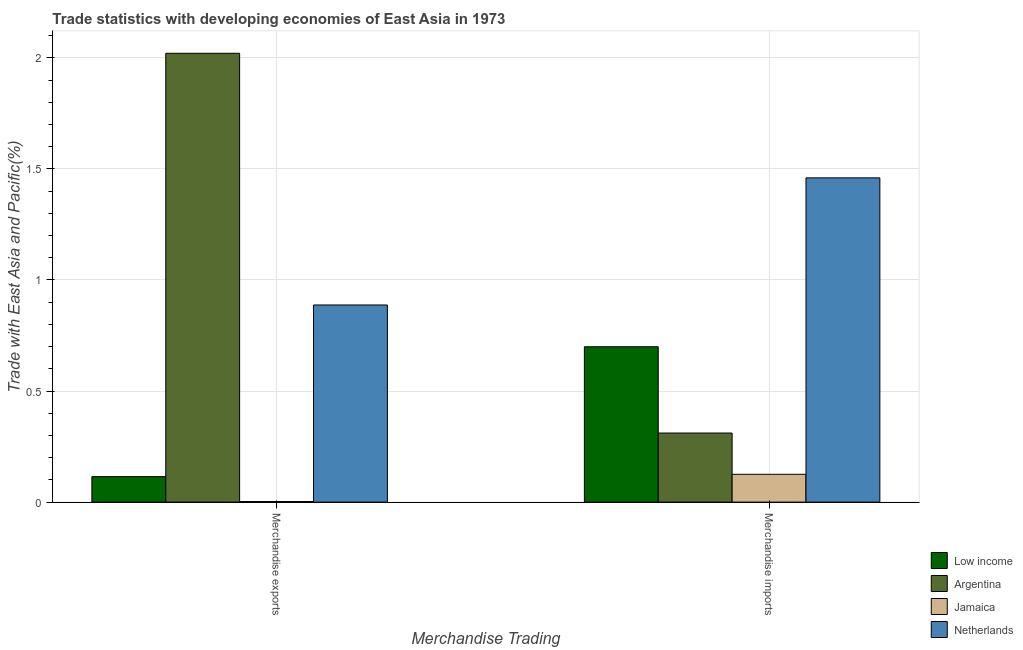How many different coloured bars are there?
Your response must be concise. 4. How many groups of bars are there?
Provide a succinct answer. 2. What is the label of the 1st group of bars from the left?
Ensure brevity in your answer.  Merchandise exports. What is the merchandise exports in Argentina?
Your response must be concise. 2.02. Across all countries, what is the maximum merchandise exports?
Offer a terse response. 2.02. Across all countries, what is the minimum merchandise exports?
Ensure brevity in your answer.  0. In which country was the merchandise exports maximum?
Make the answer very short. Argentina. In which country was the merchandise imports minimum?
Your answer should be very brief. Jamaica. What is the total merchandise exports in the graph?
Provide a short and direct response. 3.03. What is the difference between the merchandise imports in Netherlands and that in Jamaica?
Make the answer very short. 1.33. What is the difference between the merchandise imports in Low income and the merchandise exports in Jamaica?
Provide a succinct answer. 0.7. What is the average merchandise imports per country?
Your response must be concise. 0.65. What is the difference between the merchandise exports and merchandise imports in Low income?
Offer a very short reply. -0.58. What is the ratio of the merchandise exports in Netherlands to that in Low income?
Give a very brief answer. 7.74. Is the merchandise exports in Jamaica less than that in Netherlands?
Offer a very short reply. Yes. What does the 2nd bar from the right in Merchandise imports represents?
Give a very brief answer. Jamaica. How many bars are there?
Keep it short and to the point. 8. Are all the bars in the graph horizontal?
Make the answer very short. No. How many countries are there in the graph?
Make the answer very short. 4. What is the difference between two consecutive major ticks on the Y-axis?
Keep it short and to the point. 0.5. Are the values on the major ticks of Y-axis written in scientific E-notation?
Your answer should be very brief. No. Does the graph contain any zero values?
Ensure brevity in your answer.  No. Does the graph contain grids?
Your response must be concise. Yes. Where does the legend appear in the graph?
Your answer should be compact. Bottom right. How many legend labels are there?
Make the answer very short. 4. What is the title of the graph?
Your response must be concise. Trade statistics with developing economies of East Asia in 1973. What is the label or title of the X-axis?
Your response must be concise. Merchandise Trading. What is the label or title of the Y-axis?
Provide a succinct answer. Trade with East Asia and Pacific(%). What is the Trade with East Asia and Pacific(%) in Low income in Merchandise exports?
Make the answer very short. 0.11. What is the Trade with East Asia and Pacific(%) of Argentina in Merchandise exports?
Make the answer very short. 2.02. What is the Trade with East Asia and Pacific(%) of Jamaica in Merchandise exports?
Provide a succinct answer. 0. What is the Trade with East Asia and Pacific(%) of Netherlands in Merchandise exports?
Your response must be concise. 0.89. What is the Trade with East Asia and Pacific(%) of Low income in Merchandise imports?
Ensure brevity in your answer.  0.7. What is the Trade with East Asia and Pacific(%) of Argentina in Merchandise imports?
Your answer should be compact. 0.31. What is the Trade with East Asia and Pacific(%) in Jamaica in Merchandise imports?
Provide a succinct answer. 0.13. What is the Trade with East Asia and Pacific(%) of Netherlands in Merchandise imports?
Provide a succinct answer. 1.46. Across all Merchandise Trading, what is the maximum Trade with East Asia and Pacific(%) of Low income?
Your answer should be compact. 0.7. Across all Merchandise Trading, what is the maximum Trade with East Asia and Pacific(%) of Argentina?
Give a very brief answer. 2.02. Across all Merchandise Trading, what is the maximum Trade with East Asia and Pacific(%) of Jamaica?
Provide a short and direct response. 0.13. Across all Merchandise Trading, what is the maximum Trade with East Asia and Pacific(%) of Netherlands?
Keep it short and to the point. 1.46. Across all Merchandise Trading, what is the minimum Trade with East Asia and Pacific(%) in Low income?
Ensure brevity in your answer.  0.11. Across all Merchandise Trading, what is the minimum Trade with East Asia and Pacific(%) in Argentina?
Give a very brief answer. 0.31. Across all Merchandise Trading, what is the minimum Trade with East Asia and Pacific(%) of Jamaica?
Your response must be concise. 0. Across all Merchandise Trading, what is the minimum Trade with East Asia and Pacific(%) of Netherlands?
Your answer should be compact. 0.89. What is the total Trade with East Asia and Pacific(%) in Low income in the graph?
Provide a succinct answer. 0.81. What is the total Trade with East Asia and Pacific(%) in Argentina in the graph?
Ensure brevity in your answer.  2.33. What is the total Trade with East Asia and Pacific(%) of Jamaica in the graph?
Offer a terse response. 0.13. What is the total Trade with East Asia and Pacific(%) of Netherlands in the graph?
Make the answer very short. 2.35. What is the difference between the Trade with East Asia and Pacific(%) in Low income in Merchandise exports and that in Merchandise imports?
Your answer should be very brief. -0.58. What is the difference between the Trade with East Asia and Pacific(%) of Argentina in Merchandise exports and that in Merchandise imports?
Offer a very short reply. 1.71. What is the difference between the Trade with East Asia and Pacific(%) in Jamaica in Merchandise exports and that in Merchandise imports?
Your answer should be very brief. -0.12. What is the difference between the Trade with East Asia and Pacific(%) in Netherlands in Merchandise exports and that in Merchandise imports?
Keep it short and to the point. -0.57. What is the difference between the Trade with East Asia and Pacific(%) of Low income in Merchandise exports and the Trade with East Asia and Pacific(%) of Argentina in Merchandise imports?
Offer a very short reply. -0.2. What is the difference between the Trade with East Asia and Pacific(%) in Low income in Merchandise exports and the Trade with East Asia and Pacific(%) in Jamaica in Merchandise imports?
Ensure brevity in your answer.  -0.01. What is the difference between the Trade with East Asia and Pacific(%) of Low income in Merchandise exports and the Trade with East Asia and Pacific(%) of Netherlands in Merchandise imports?
Give a very brief answer. -1.34. What is the difference between the Trade with East Asia and Pacific(%) of Argentina in Merchandise exports and the Trade with East Asia and Pacific(%) of Jamaica in Merchandise imports?
Give a very brief answer. 1.9. What is the difference between the Trade with East Asia and Pacific(%) of Argentina in Merchandise exports and the Trade with East Asia and Pacific(%) of Netherlands in Merchandise imports?
Make the answer very short. 0.56. What is the difference between the Trade with East Asia and Pacific(%) in Jamaica in Merchandise exports and the Trade with East Asia and Pacific(%) in Netherlands in Merchandise imports?
Your response must be concise. -1.46. What is the average Trade with East Asia and Pacific(%) of Low income per Merchandise Trading?
Keep it short and to the point. 0.41. What is the average Trade with East Asia and Pacific(%) in Argentina per Merchandise Trading?
Offer a very short reply. 1.17. What is the average Trade with East Asia and Pacific(%) in Jamaica per Merchandise Trading?
Ensure brevity in your answer.  0.06. What is the average Trade with East Asia and Pacific(%) in Netherlands per Merchandise Trading?
Make the answer very short. 1.17. What is the difference between the Trade with East Asia and Pacific(%) of Low income and Trade with East Asia and Pacific(%) of Argentina in Merchandise exports?
Your response must be concise. -1.91. What is the difference between the Trade with East Asia and Pacific(%) of Low income and Trade with East Asia and Pacific(%) of Jamaica in Merchandise exports?
Give a very brief answer. 0.11. What is the difference between the Trade with East Asia and Pacific(%) in Low income and Trade with East Asia and Pacific(%) in Netherlands in Merchandise exports?
Your response must be concise. -0.77. What is the difference between the Trade with East Asia and Pacific(%) of Argentina and Trade with East Asia and Pacific(%) of Jamaica in Merchandise exports?
Provide a short and direct response. 2.02. What is the difference between the Trade with East Asia and Pacific(%) of Argentina and Trade with East Asia and Pacific(%) of Netherlands in Merchandise exports?
Provide a succinct answer. 1.13. What is the difference between the Trade with East Asia and Pacific(%) of Jamaica and Trade with East Asia and Pacific(%) of Netherlands in Merchandise exports?
Your answer should be compact. -0.88. What is the difference between the Trade with East Asia and Pacific(%) in Low income and Trade with East Asia and Pacific(%) in Argentina in Merchandise imports?
Give a very brief answer. 0.39. What is the difference between the Trade with East Asia and Pacific(%) in Low income and Trade with East Asia and Pacific(%) in Jamaica in Merchandise imports?
Make the answer very short. 0.57. What is the difference between the Trade with East Asia and Pacific(%) of Low income and Trade with East Asia and Pacific(%) of Netherlands in Merchandise imports?
Provide a succinct answer. -0.76. What is the difference between the Trade with East Asia and Pacific(%) in Argentina and Trade with East Asia and Pacific(%) in Jamaica in Merchandise imports?
Your answer should be very brief. 0.19. What is the difference between the Trade with East Asia and Pacific(%) of Argentina and Trade with East Asia and Pacific(%) of Netherlands in Merchandise imports?
Offer a very short reply. -1.15. What is the difference between the Trade with East Asia and Pacific(%) of Jamaica and Trade with East Asia and Pacific(%) of Netherlands in Merchandise imports?
Give a very brief answer. -1.33. What is the ratio of the Trade with East Asia and Pacific(%) of Low income in Merchandise exports to that in Merchandise imports?
Keep it short and to the point. 0.16. What is the ratio of the Trade with East Asia and Pacific(%) of Argentina in Merchandise exports to that in Merchandise imports?
Your answer should be compact. 6.5. What is the ratio of the Trade with East Asia and Pacific(%) of Jamaica in Merchandise exports to that in Merchandise imports?
Your response must be concise. 0.02. What is the ratio of the Trade with East Asia and Pacific(%) of Netherlands in Merchandise exports to that in Merchandise imports?
Provide a succinct answer. 0.61. What is the difference between the highest and the second highest Trade with East Asia and Pacific(%) of Low income?
Provide a short and direct response. 0.58. What is the difference between the highest and the second highest Trade with East Asia and Pacific(%) in Argentina?
Your response must be concise. 1.71. What is the difference between the highest and the second highest Trade with East Asia and Pacific(%) of Jamaica?
Provide a succinct answer. 0.12. What is the difference between the highest and the second highest Trade with East Asia and Pacific(%) in Netherlands?
Your answer should be compact. 0.57. What is the difference between the highest and the lowest Trade with East Asia and Pacific(%) of Low income?
Keep it short and to the point. 0.58. What is the difference between the highest and the lowest Trade with East Asia and Pacific(%) of Argentina?
Provide a short and direct response. 1.71. What is the difference between the highest and the lowest Trade with East Asia and Pacific(%) in Jamaica?
Ensure brevity in your answer.  0.12. What is the difference between the highest and the lowest Trade with East Asia and Pacific(%) of Netherlands?
Your response must be concise. 0.57. 